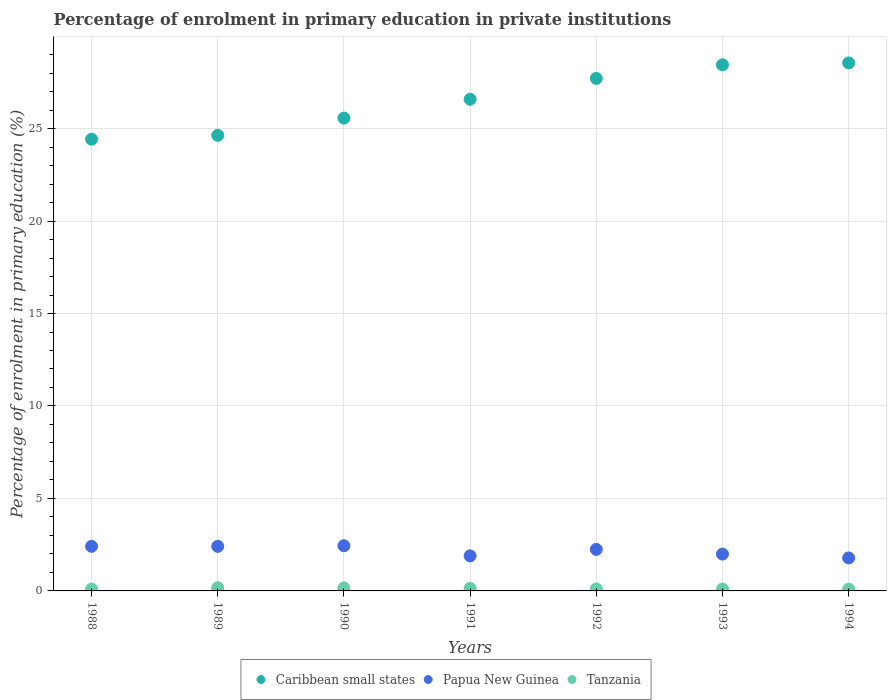How many different coloured dotlines are there?
Make the answer very short. 3. Is the number of dotlines equal to the number of legend labels?
Provide a succinct answer. Yes. What is the percentage of enrolment in primary education in Tanzania in 1989?
Offer a terse response. 0.17. Across all years, what is the maximum percentage of enrolment in primary education in Caribbean small states?
Offer a terse response. 28.55. Across all years, what is the minimum percentage of enrolment in primary education in Papua New Guinea?
Give a very brief answer. 1.78. In which year was the percentage of enrolment in primary education in Papua New Guinea maximum?
Provide a short and direct response. 1990. What is the total percentage of enrolment in primary education in Caribbean small states in the graph?
Make the answer very short. 185.92. What is the difference between the percentage of enrolment in primary education in Papua New Guinea in 1988 and that in 1989?
Your response must be concise. 0. What is the difference between the percentage of enrolment in primary education in Caribbean small states in 1993 and the percentage of enrolment in primary education in Papua New Guinea in 1992?
Offer a very short reply. 26.2. What is the average percentage of enrolment in primary education in Papua New Guinea per year?
Make the answer very short. 2.17. In the year 1990, what is the difference between the percentage of enrolment in primary education in Papua New Guinea and percentage of enrolment in primary education in Caribbean small states?
Offer a very short reply. -23.12. In how many years, is the percentage of enrolment in primary education in Tanzania greater than 20 %?
Ensure brevity in your answer.  0. What is the ratio of the percentage of enrolment in primary education in Papua New Guinea in 1991 to that in 1994?
Provide a succinct answer. 1.06. Is the difference between the percentage of enrolment in primary education in Papua New Guinea in 1990 and 1994 greater than the difference between the percentage of enrolment in primary education in Caribbean small states in 1990 and 1994?
Ensure brevity in your answer.  Yes. What is the difference between the highest and the second highest percentage of enrolment in primary education in Tanzania?
Ensure brevity in your answer.  0.01. What is the difference between the highest and the lowest percentage of enrolment in primary education in Tanzania?
Give a very brief answer. 0.08. In how many years, is the percentage of enrolment in primary education in Papua New Guinea greater than the average percentage of enrolment in primary education in Papua New Guinea taken over all years?
Offer a very short reply. 4. Is it the case that in every year, the sum of the percentage of enrolment in primary education in Papua New Guinea and percentage of enrolment in primary education in Tanzania  is greater than the percentage of enrolment in primary education in Caribbean small states?
Offer a very short reply. No. Does the percentage of enrolment in primary education in Tanzania monotonically increase over the years?
Give a very brief answer. No. Is the percentage of enrolment in primary education in Tanzania strictly greater than the percentage of enrolment in primary education in Caribbean small states over the years?
Provide a short and direct response. No. Is the percentage of enrolment in primary education in Caribbean small states strictly less than the percentage of enrolment in primary education in Papua New Guinea over the years?
Offer a very short reply. No. How many dotlines are there?
Make the answer very short. 3. How many years are there in the graph?
Ensure brevity in your answer.  7. What is the difference between two consecutive major ticks on the Y-axis?
Provide a short and direct response. 5. Are the values on the major ticks of Y-axis written in scientific E-notation?
Give a very brief answer. No. Where does the legend appear in the graph?
Make the answer very short. Bottom center. How many legend labels are there?
Your response must be concise. 3. How are the legend labels stacked?
Offer a terse response. Horizontal. What is the title of the graph?
Offer a terse response. Percentage of enrolment in primary education in private institutions. What is the label or title of the Y-axis?
Offer a terse response. Percentage of enrolment in primary education (%). What is the Percentage of enrolment in primary education (%) of Caribbean small states in 1988?
Your answer should be very brief. 24.43. What is the Percentage of enrolment in primary education (%) of Papua New Guinea in 1988?
Ensure brevity in your answer.  2.41. What is the Percentage of enrolment in primary education (%) in Tanzania in 1988?
Offer a very short reply. 0.1. What is the Percentage of enrolment in primary education (%) in Caribbean small states in 1989?
Provide a succinct answer. 24.64. What is the Percentage of enrolment in primary education (%) in Papua New Guinea in 1989?
Provide a succinct answer. 2.41. What is the Percentage of enrolment in primary education (%) of Tanzania in 1989?
Offer a very short reply. 0.17. What is the Percentage of enrolment in primary education (%) in Caribbean small states in 1990?
Offer a terse response. 25.57. What is the Percentage of enrolment in primary education (%) in Papua New Guinea in 1990?
Ensure brevity in your answer.  2.44. What is the Percentage of enrolment in primary education (%) in Tanzania in 1990?
Offer a very short reply. 0.17. What is the Percentage of enrolment in primary education (%) of Caribbean small states in 1991?
Your response must be concise. 26.59. What is the Percentage of enrolment in primary education (%) of Papua New Guinea in 1991?
Make the answer very short. 1.9. What is the Percentage of enrolment in primary education (%) of Tanzania in 1991?
Ensure brevity in your answer.  0.14. What is the Percentage of enrolment in primary education (%) in Caribbean small states in 1992?
Your answer should be compact. 27.71. What is the Percentage of enrolment in primary education (%) of Papua New Guinea in 1992?
Provide a succinct answer. 2.25. What is the Percentage of enrolment in primary education (%) of Tanzania in 1992?
Your response must be concise. 0.11. What is the Percentage of enrolment in primary education (%) of Caribbean small states in 1993?
Offer a very short reply. 28.45. What is the Percentage of enrolment in primary education (%) in Papua New Guinea in 1993?
Offer a very short reply. 1.99. What is the Percentage of enrolment in primary education (%) of Tanzania in 1993?
Your response must be concise. 0.1. What is the Percentage of enrolment in primary education (%) in Caribbean small states in 1994?
Give a very brief answer. 28.55. What is the Percentage of enrolment in primary education (%) of Papua New Guinea in 1994?
Offer a very short reply. 1.78. What is the Percentage of enrolment in primary education (%) in Tanzania in 1994?
Your answer should be very brief. 0.1. Across all years, what is the maximum Percentage of enrolment in primary education (%) in Caribbean small states?
Offer a very short reply. 28.55. Across all years, what is the maximum Percentage of enrolment in primary education (%) of Papua New Guinea?
Keep it short and to the point. 2.44. Across all years, what is the maximum Percentage of enrolment in primary education (%) of Tanzania?
Your answer should be very brief. 0.17. Across all years, what is the minimum Percentage of enrolment in primary education (%) of Caribbean small states?
Your response must be concise. 24.43. Across all years, what is the minimum Percentage of enrolment in primary education (%) of Papua New Guinea?
Make the answer very short. 1.78. Across all years, what is the minimum Percentage of enrolment in primary education (%) in Tanzania?
Ensure brevity in your answer.  0.1. What is the total Percentage of enrolment in primary education (%) in Caribbean small states in the graph?
Make the answer very short. 185.92. What is the total Percentage of enrolment in primary education (%) of Papua New Guinea in the graph?
Ensure brevity in your answer.  15.18. What is the total Percentage of enrolment in primary education (%) in Tanzania in the graph?
Keep it short and to the point. 0.89. What is the difference between the Percentage of enrolment in primary education (%) in Caribbean small states in 1988 and that in 1989?
Your answer should be compact. -0.21. What is the difference between the Percentage of enrolment in primary education (%) in Tanzania in 1988 and that in 1989?
Your answer should be very brief. -0.08. What is the difference between the Percentage of enrolment in primary education (%) in Caribbean small states in 1988 and that in 1990?
Your answer should be compact. -1.14. What is the difference between the Percentage of enrolment in primary education (%) of Papua New Guinea in 1988 and that in 1990?
Provide a short and direct response. -0.03. What is the difference between the Percentage of enrolment in primary education (%) of Tanzania in 1988 and that in 1990?
Your answer should be compact. -0.07. What is the difference between the Percentage of enrolment in primary education (%) in Caribbean small states in 1988 and that in 1991?
Provide a short and direct response. -2.16. What is the difference between the Percentage of enrolment in primary education (%) in Papua New Guinea in 1988 and that in 1991?
Offer a very short reply. 0.52. What is the difference between the Percentage of enrolment in primary education (%) in Tanzania in 1988 and that in 1991?
Give a very brief answer. -0.04. What is the difference between the Percentage of enrolment in primary education (%) of Caribbean small states in 1988 and that in 1992?
Give a very brief answer. -3.29. What is the difference between the Percentage of enrolment in primary education (%) of Papua New Guinea in 1988 and that in 1992?
Your answer should be compact. 0.17. What is the difference between the Percentage of enrolment in primary education (%) of Tanzania in 1988 and that in 1992?
Your answer should be very brief. -0.01. What is the difference between the Percentage of enrolment in primary education (%) of Caribbean small states in 1988 and that in 1993?
Ensure brevity in your answer.  -4.02. What is the difference between the Percentage of enrolment in primary education (%) of Papua New Guinea in 1988 and that in 1993?
Provide a short and direct response. 0.42. What is the difference between the Percentage of enrolment in primary education (%) of Tanzania in 1988 and that in 1993?
Provide a short and direct response. -0. What is the difference between the Percentage of enrolment in primary education (%) in Caribbean small states in 1988 and that in 1994?
Make the answer very short. -4.13. What is the difference between the Percentage of enrolment in primary education (%) of Papua New Guinea in 1988 and that in 1994?
Offer a very short reply. 0.63. What is the difference between the Percentage of enrolment in primary education (%) of Tanzania in 1988 and that in 1994?
Ensure brevity in your answer.  0. What is the difference between the Percentage of enrolment in primary education (%) of Caribbean small states in 1989 and that in 1990?
Keep it short and to the point. -0.93. What is the difference between the Percentage of enrolment in primary education (%) in Papua New Guinea in 1989 and that in 1990?
Your response must be concise. -0.03. What is the difference between the Percentage of enrolment in primary education (%) of Tanzania in 1989 and that in 1990?
Ensure brevity in your answer.  0.01. What is the difference between the Percentage of enrolment in primary education (%) in Caribbean small states in 1989 and that in 1991?
Your answer should be compact. -1.95. What is the difference between the Percentage of enrolment in primary education (%) in Papua New Guinea in 1989 and that in 1991?
Offer a very short reply. 0.52. What is the difference between the Percentage of enrolment in primary education (%) of Tanzania in 1989 and that in 1991?
Your answer should be very brief. 0.03. What is the difference between the Percentage of enrolment in primary education (%) in Caribbean small states in 1989 and that in 1992?
Give a very brief answer. -3.08. What is the difference between the Percentage of enrolment in primary education (%) in Papua New Guinea in 1989 and that in 1992?
Offer a terse response. 0.16. What is the difference between the Percentage of enrolment in primary education (%) in Tanzania in 1989 and that in 1992?
Keep it short and to the point. 0.07. What is the difference between the Percentage of enrolment in primary education (%) in Caribbean small states in 1989 and that in 1993?
Provide a succinct answer. -3.81. What is the difference between the Percentage of enrolment in primary education (%) of Papua New Guinea in 1989 and that in 1993?
Offer a very short reply. 0.42. What is the difference between the Percentage of enrolment in primary education (%) of Tanzania in 1989 and that in 1993?
Provide a succinct answer. 0.07. What is the difference between the Percentage of enrolment in primary education (%) in Caribbean small states in 1989 and that in 1994?
Provide a short and direct response. -3.92. What is the difference between the Percentage of enrolment in primary education (%) of Papua New Guinea in 1989 and that in 1994?
Offer a very short reply. 0.63. What is the difference between the Percentage of enrolment in primary education (%) of Tanzania in 1989 and that in 1994?
Your response must be concise. 0.08. What is the difference between the Percentage of enrolment in primary education (%) of Caribbean small states in 1990 and that in 1991?
Offer a very short reply. -1.02. What is the difference between the Percentage of enrolment in primary education (%) in Papua New Guinea in 1990 and that in 1991?
Keep it short and to the point. 0.55. What is the difference between the Percentage of enrolment in primary education (%) in Tanzania in 1990 and that in 1991?
Your answer should be very brief. 0.03. What is the difference between the Percentage of enrolment in primary education (%) in Caribbean small states in 1990 and that in 1992?
Offer a terse response. -2.15. What is the difference between the Percentage of enrolment in primary education (%) in Papua New Guinea in 1990 and that in 1992?
Your answer should be compact. 0.2. What is the difference between the Percentage of enrolment in primary education (%) in Tanzania in 1990 and that in 1992?
Offer a terse response. 0.06. What is the difference between the Percentage of enrolment in primary education (%) of Caribbean small states in 1990 and that in 1993?
Give a very brief answer. -2.88. What is the difference between the Percentage of enrolment in primary education (%) in Papua New Guinea in 1990 and that in 1993?
Make the answer very short. 0.45. What is the difference between the Percentage of enrolment in primary education (%) in Tanzania in 1990 and that in 1993?
Keep it short and to the point. 0.07. What is the difference between the Percentage of enrolment in primary education (%) in Caribbean small states in 1990 and that in 1994?
Offer a very short reply. -2.99. What is the difference between the Percentage of enrolment in primary education (%) of Papua New Guinea in 1990 and that in 1994?
Provide a succinct answer. 0.66. What is the difference between the Percentage of enrolment in primary education (%) in Tanzania in 1990 and that in 1994?
Give a very brief answer. 0.07. What is the difference between the Percentage of enrolment in primary education (%) of Caribbean small states in 1991 and that in 1992?
Your response must be concise. -1.13. What is the difference between the Percentage of enrolment in primary education (%) in Papua New Guinea in 1991 and that in 1992?
Your response must be concise. -0.35. What is the difference between the Percentage of enrolment in primary education (%) of Tanzania in 1991 and that in 1992?
Your response must be concise. 0.03. What is the difference between the Percentage of enrolment in primary education (%) of Caribbean small states in 1991 and that in 1993?
Provide a succinct answer. -1.86. What is the difference between the Percentage of enrolment in primary education (%) of Papua New Guinea in 1991 and that in 1993?
Your answer should be compact. -0.1. What is the difference between the Percentage of enrolment in primary education (%) of Tanzania in 1991 and that in 1993?
Your answer should be very brief. 0.04. What is the difference between the Percentage of enrolment in primary education (%) of Caribbean small states in 1991 and that in 1994?
Your response must be concise. -1.97. What is the difference between the Percentage of enrolment in primary education (%) in Papua New Guinea in 1991 and that in 1994?
Provide a succinct answer. 0.11. What is the difference between the Percentage of enrolment in primary education (%) in Tanzania in 1991 and that in 1994?
Your answer should be compact. 0.05. What is the difference between the Percentage of enrolment in primary education (%) in Caribbean small states in 1992 and that in 1993?
Make the answer very short. -0.73. What is the difference between the Percentage of enrolment in primary education (%) in Papua New Guinea in 1992 and that in 1993?
Offer a terse response. 0.25. What is the difference between the Percentage of enrolment in primary education (%) in Tanzania in 1992 and that in 1993?
Provide a short and direct response. 0.01. What is the difference between the Percentage of enrolment in primary education (%) of Caribbean small states in 1992 and that in 1994?
Your response must be concise. -0.84. What is the difference between the Percentage of enrolment in primary education (%) in Papua New Guinea in 1992 and that in 1994?
Your response must be concise. 0.46. What is the difference between the Percentage of enrolment in primary education (%) of Tanzania in 1992 and that in 1994?
Give a very brief answer. 0.01. What is the difference between the Percentage of enrolment in primary education (%) of Caribbean small states in 1993 and that in 1994?
Ensure brevity in your answer.  -0.11. What is the difference between the Percentage of enrolment in primary education (%) in Papua New Guinea in 1993 and that in 1994?
Offer a terse response. 0.21. What is the difference between the Percentage of enrolment in primary education (%) in Tanzania in 1993 and that in 1994?
Offer a very short reply. 0.01. What is the difference between the Percentage of enrolment in primary education (%) of Caribbean small states in 1988 and the Percentage of enrolment in primary education (%) of Papua New Guinea in 1989?
Keep it short and to the point. 22.02. What is the difference between the Percentage of enrolment in primary education (%) of Caribbean small states in 1988 and the Percentage of enrolment in primary education (%) of Tanzania in 1989?
Your response must be concise. 24.25. What is the difference between the Percentage of enrolment in primary education (%) in Papua New Guinea in 1988 and the Percentage of enrolment in primary education (%) in Tanzania in 1989?
Provide a short and direct response. 2.24. What is the difference between the Percentage of enrolment in primary education (%) of Caribbean small states in 1988 and the Percentage of enrolment in primary education (%) of Papua New Guinea in 1990?
Your answer should be very brief. 21.98. What is the difference between the Percentage of enrolment in primary education (%) in Caribbean small states in 1988 and the Percentage of enrolment in primary education (%) in Tanzania in 1990?
Offer a terse response. 24.26. What is the difference between the Percentage of enrolment in primary education (%) of Papua New Guinea in 1988 and the Percentage of enrolment in primary education (%) of Tanzania in 1990?
Ensure brevity in your answer.  2.24. What is the difference between the Percentage of enrolment in primary education (%) in Caribbean small states in 1988 and the Percentage of enrolment in primary education (%) in Papua New Guinea in 1991?
Your response must be concise. 22.53. What is the difference between the Percentage of enrolment in primary education (%) of Caribbean small states in 1988 and the Percentage of enrolment in primary education (%) of Tanzania in 1991?
Provide a succinct answer. 24.28. What is the difference between the Percentage of enrolment in primary education (%) of Papua New Guinea in 1988 and the Percentage of enrolment in primary education (%) of Tanzania in 1991?
Offer a very short reply. 2.27. What is the difference between the Percentage of enrolment in primary education (%) in Caribbean small states in 1988 and the Percentage of enrolment in primary education (%) in Papua New Guinea in 1992?
Keep it short and to the point. 22.18. What is the difference between the Percentage of enrolment in primary education (%) of Caribbean small states in 1988 and the Percentage of enrolment in primary education (%) of Tanzania in 1992?
Provide a short and direct response. 24.32. What is the difference between the Percentage of enrolment in primary education (%) in Papua New Guinea in 1988 and the Percentage of enrolment in primary education (%) in Tanzania in 1992?
Ensure brevity in your answer.  2.3. What is the difference between the Percentage of enrolment in primary education (%) in Caribbean small states in 1988 and the Percentage of enrolment in primary education (%) in Papua New Guinea in 1993?
Make the answer very short. 22.43. What is the difference between the Percentage of enrolment in primary education (%) in Caribbean small states in 1988 and the Percentage of enrolment in primary education (%) in Tanzania in 1993?
Provide a short and direct response. 24.32. What is the difference between the Percentage of enrolment in primary education (%) of Papua New Guinea in 1988 and the Percentage of enrolment in primary education (%) of Tanzania in 1993?
Give a very brief answer. 2.31. What is the difference between the Percentage of enrolment in primary education (%) of Caribbean small states in 1988 and the Percentage of enrolment in primary education (%) of Papua New Guinea in 1994?
Your response must be concise. 22.64. What is the difference between the Percentage of enrolment in primary education (%) of Caribbean small states in 1988 and the Percentage of enrolment in primary education (%) of Tanzania in 1994?
Provide a succinct answer. 24.33. What is the difference between the Percentage of enrolment in primary education (%) in Papua New Guinea in 1988 and the Percentage of enrolment in primary education (%) in Tanzania in 1994?
Give a very brief answer. 2.31. What is the difference between the Percentage of enrolment in primary education (%) of Caribbean small states in 1989 and the Percentage of enrolment in primary education (%) of Papua New Guinea in 1990?
Give a very brief answer. 22.19. What is the difference between the Percentage of enrolment in primary education (%) in Caribbean small states in 1989 and the Percentage of enrolment in primary education (%) in Tanzania in 1990?
Your response must be concise. 24.47. What is the difference between the Percentage of enrolment in primary education (%) of Papua New Guinea in 1989 and the Percentage of enrolment in primary education (%) of Tanzania in 1990?
Make the answer very short. 2.24. What is the difference between the Percentage of enrolment in primary education (%) of Caribbean small states in 1989 and the Percentage of enrolment in primary education (%) of Papua New Guinea in 1991?
Your answer should be very brief. 22.74. What is the difference between the Percentage of enrolment in primary education (%) of Caribbean small states in 1989 and the Percentage of enrolment in primary education (%) of Tanzania in 1991?
Provide a succinct answer. 24.49. What is the difference between the Percentage of enrolment in primary education (%) of Papua New Guinea in 1989 and the Percentage of enrolment in primary education (%) of Tanzania in 1991?
Your answer should be very brief. 2.27. What is the difference between the Percentage of enrolment in primary education (%) in Caribbean small states in 1989 and the Percentage of enrolment in primary education (%) in Papua New Guinea in 1992?
Provide a succinct answer. 22.39. What is the difference between the Percentage of enrolment in primary education (%) of Caribbean small states in 1989 and the Percentage of enrolment in primary education (%) of Tanzania in 1992?
Offer a very short reply. 24.53. What is the difference between the Percentage of enrolment in primary education (%) in Papua New Guinea in 1989 and the Percentage of enrolment in primary education (%) in Tanzania in 1992?
Give a very brief answer. 2.3. What is the difference between the Percentage of enrolment in primary education (%) of Caribbean small states in 1989 and the Percentage of enrolment in primary education (%) of Papua New Guinea in 1993?
Provide a short and direct response. 22.64. What is the difference between the Percentage of enrolment in primary education (%) of Caribbean small states in 1989 and the Percentage of enrolment in primary education (%) of Tanzania in 1993?
Give a very brief answer. 24.53. What is the difference between the Percentage of enrolment in primary education (%) of Papua New Guinea in 1989 and the Percentage of enrolment in primary education (%) of Tanzania in 1993?
Ensure brevity in your answer.  2.31. What is the difference between the Percentage of enrolment in primary education (%) of Caribbean small states in 1989 and the Percentage of enrolment in primary education (%) of Papua New Guinea in 1994?
Your response must be concise. 22.85. What is the difference between the Percentage of enrolment in primary education (%) in Caribbean small states in 1989 and the Percentage of enrolment in primary education (%) in Tanzania in 1994?
Offer a terse response. 24.54. What is the difference between the Percentage of enrolment in primary education (%) in Papua New Guinea in 1989 and the Percentage of enrolment in primary education (%) in Tanzania in 1994?
Your answer should be very brief. 2.31. What is the difference between the Percentage of enrolment in primary education (%) in Caribbean small states in 1990 and the Percentage of enrolment in primary education (%) in Papua New Guinea in 1991?
Your answer should be compact. 23.67. What is the difference between the Percentage of enrolment in primary education (%) in Caribbean small states in 1990 and the Percentage of enrolment in primary education (%) in Tanzania in 1991?
Give a very brief answer. 25.43. What is the difference between the Percentage of enrolment in primary education (%) of Papua New Guinea in 1990 and the Percentage of enrolment in primary education (%) of Tanzania in 1991?
Make the answer very short. 2.3. What is the difference between the Percentage of enrolment in primary education (%) in Caribbean small states in 1990 and the Percentage of enrolment in primary education (%) in Papua New Guinea in 1992?
Offer a terse response. 23.32. What is the difference between the Percentage of enrolment in primary education (%) of Caribbean small states in 1990 and the Percentage of enrolment in primary education (%) of Tanzania in 1992?
Offer a terse response. 25.46. What is the difference between the Percentage of enrolment in primary education (%) in Papua New Guinea in 1990 and the Percentage of enrolment in primary education (%) in Tanzania in 1992?
Your response must be concise. 2.33. What is the difference between the Percentage of enrolment in primary education (%) in Caribbean small states in 1990 and the Percentage of enrolment in primary education (%) in Papua New Guinea in 1993?
Make the answer very short. 23.58. What is the difference between the Percentage of enrolment in primary education (%) in Caribbean small states in 1990 and the Percentage of enrolment in primary education (%) in Tanzania in 1993?
Give a very brief answer. 25.47. What is the difference between the Percentage of enrolment in primary education (%) in Papua New Guinea in 1990 and the Percentage of enrolment in primary education (%) in Tanzania in 1993?
Ensure brevity in your answer.  2.34. What is the difference between the Percentage of enrolment in primary education (%) of Caribbean small states in 1990 and the Percentage of enrolment in primary education (%) of Papua New Guinea in 1994?
Your answer should be compact. 23.78. What is the difference between the Percentage of enrolment in primary education (%) of Caribbean small states in 1990 and the Percentage of enrolment in primary education (%) of Tanzania in 1994?
Make the answer very short. 25.47. What is the difference between the Percentage of enrolment in primary education (%) in Papua New Guinea in 1990 and the Percentage of enrolment in primary education (%) in Tanzania in 1994?
Ensure brevity in your answer.  2.35. What is the difference between the Percentage of enrolment in primary education (%) of Caribbean small states in 1991 and the Percentage of enrolment in primary education (%) of Papua New Guinea in 1992?
Keep it short and to the point. 24.34. What is the difference between the Percentage of enrolment in primary education (%) of Caribbean small states in 1991 and the Percentage of enrolment in primary education (%) of Tanzania in 1992?
Your answer should be compact. 26.48. What is the difference between the Percentage of enrolment in primary education (%) of Papua New Guinea in 1991 and the Percentage of enrolment in primary education (%) of Tanzania in 1992?
Ensure brevity in your answer.  1.79. What is the difference between the Percentage of enrolment in primary education (%) of Caribbean small states in 1991 and the Percentage of enrolment in primary education (%) of Papua New Guinea in 1993?
Offer a very short reply. 24.59. What is the difference between the Percentage of enrolment in primary education (%) in Caribbean small states in 1991 and the Percentage of enrolment in primary education (%) in Tanzania in 1993?
Keep it short and to the point. 26.48. What is the difference between the Percentage of enrolment in primary education (%) in Papua New Guinea in 1991 and the Percentage of enrolment in primary education (%) in Tanzania in 1993?
Ensure brevity in your answer.  1.79. What is the difference between the Percentage of enrolment in primary education (%) of Caribbean small states in 1991 and the Percentage of enrolment in primary education (%) of Papua New Guinea in 1994?
Give a very brief answer. 24.8. What is the difference between the Percentage of enrolment in primary education (%) of Caribbean small states in 1991 and the Percentage of enrolment in primary education (%) of Tanzania in 1994?
Your response must be concise. 26.49. What is the difference between the Percentage of enrolment in primary education (%) in Papua New Guinea in 1991 and the Percentage of enrolment in primary education (%) in Tanzania in 1994?
Your answer should be very brief. 1.8. What is the difference between the Percentage of enrolment in primary education (%) of Caribbean small states in 1992 and the Percentage of enrolment in primary education (%) of Papua New Guinea in 1993?
Give a very brief answer. 25.72. What is the difference between the Percentage of enrolment in primary education (%) in Caribbean small states in 1992 and the Percentage of enrolment in primary education (%) in Tanzania in 1993?
Ensure brevity in your answer.  27.61. What is the difference between the Percentage of enrolment in primary education (%) in Papua New Guinea in 1992 and the Percentage of enrolment in primary education (%) in Tanzania in 1993?
Your answer should be very brief. 2.14. What is the difference between the Percentage of enrolment in primary education (%) in Caribbean small states in 1992 and the Percentage of enrolment in primary education (%) in Papua New Guinea in 1994?
Give a very brief answer. 25.93. What is the difference between the Percentage of enrolment in primary education (%) in Caribbean small states in 1992 and the Percentage of enrolment in primary education (%) in Tanzania in 1994?
Offer a terse response. 27.62. What is the difference between the Percentage of enrolment in primary education (%) of Papua New Guinea in 1992 and the Percentage of enrolment in primary education (%) of Tanzania in 1994?
Your answer should be very brief. 2.15. What is the difference between the Percentage of enrolment in primary education (%) in Caribbean small states in 1993 and the Percentage of enrolment in primary education (%) in Papua New Guinea in 1994?
Give a very brief answer. 26.66. What is the difference between the Percentage of enrolment in primary education (%) of Caribbean small states in 1993 and the Percentage of enrolment in primary education (%) of Tanzania in 1994?
Provide a succinct answer. 28.35. What is the difference between the Percentage of enrolment in primary education (%) in Papua New Guinea in 1993 and the Percentage of enrolment in primary education (%) in Tanzania in 1994?
Ensure brevity in your answer.  1.9. What is the average Percentage of enrolment in primary education (%) in Caribbean small states per year?
Your answer should be compact. 26.56. What is the average Percentage of enrolment in primary education (%) of Papua New Guinea per year?
Offer a very short reply. 2.17. What is the average Percentage of enrolment in primary education (%) in Tanzania per year?
Give a very brief answer. 0.13. In the year 1988, what is the difference between the Percentage of enrolment in primary education (%) in Caribbean small states and Percentage of enrolment in primary education (%) in Papua New Guinea?
Your answer should be compact. 22.01. In the year 1988, what is the difference between the Percentage of enrolment in primary education (%) of Caribbean small states and Percentage of enrolment in primary education (%) of Tanzania?
Ensure brevity in your answer.  24.33. In the year 1988, what is the difference between the Percentage of enrolment in primary education (%) in Papua New Guinea and Percentage of enrolment in primary education (%) in Tanzania?
Give a very brief answer. 2.31. In the year 1989, what is the difference between the Percentage of enrolment in primary education (%) of Caribbean small states and Percentage of enrolment in primary education (%) of Papua New Guinea?
Offer a very short reply. 22.23. In the year 1989, what is the difference between the Percentage of enrolment in primary education (%) in Caribbean small states and Percentage of enrolment in primary education (%) in Tanzania?
Offer a terse response. 24.46. In the year 1989, what is the difference between the Percentage of enrolment in primary education (%) of Papua New Guinea and Percentage of enrolment in primary education (%) of Tanzania?
Your answer should be compact. 2.24. In the year 1990, what is the difference between the Percentage of enrolment in primary education (%) of Caribbean small states and Percentage of enrolment in primary education (%) of Papua New Guinea?
Keep it short and to the point. 23.12. In the year 1990, what is the difference between the Percentage of enrolment in primary education (%) in Caribbean small states and Percentage of enrolment in primary education (%) in Tanzania?
Offer a terse response. 25.4. In the year 1990, what is the difference between the Percentage of enrolment in primary education (%) of Papua New Guinea and Percentage of enrolment in primary education (%) of Tanzania?
Ensure brevity in your answer.  2.28. In the year 1991, what is the difference between the Percentage of enrolment in primary education (%) in Caribbean small states and Percentage of enrolment in primary education (%) in Papua New Guinea?
Your response must be concise. 24.69. In the year 1991, what is the difference between the Percentage of enrolment in primary education (%) in Caribbean small states and Percentage of enrolment in primary education (%) in Tanzania?
Your response must be concise. 26.44. In the year 1991, what is the difference between the Percentage of enrolment in primary education (%) in Papua New Guinea and Percentage of enrolment in primary education (%) in Tanzania?
Make the answer very short. 1.75. In the year 1992, what is the difference between the Percentage of enrolment in primary education (%) of Caribbean small states and Percentage of enrolment in primary education (%) of Papua New Guinea?
Your answer should be compact. 25.47. In the year 1992, what is the difference between the Percentage of enrolment in primary education (%) in Caribbean small states and Percentage of enrolment in primary education (%) in Tanzania?
Provide a succinct answer. 27.6. In the year 1992, what is the difference between the Percentage of enrolment in primary education (%) in Papua New Guinea and Percentage of enrolment in primary education (%) in Tanzania?
Provide a short and direct response. 2.14. In the year 1993, what is the difference between the Percentage of enrolment in primary education (%) in Caribbean small states and Percentage of enrolment in primary education (%) in Papua New Guinea?
Your answer should be very brief. 26.45. In the year 1993, what is the difference between the Percentage of enrolment in primary education (%) in Caribbean small states and Percentage of enrolment in primary education (%) in Tanzania?
Give a very brief answer. 28.34. In the year 1993, what is the difference between the Percentage of enrolment in primary education (%) in Papua New Guinea and Percentage of enrolment in primary education (%) in Tanzania?
Offer a terse response. 1.89. In the year 1994, what is the difference between the Percentage of enrolment in primary education (%) of Caribbean small states and Percentage of enrolment in primary education (%) of Papua New Guinea?
Provide a short and direct response. 26.77. In the year 1994, what is the difference between the Percentage of enrolment in primary education (%) of Caribbean small states and Percentage of enrolment in primary education (%) of Tanzania?
Your response must be concise. 28.46. In the year 1994, what is the difference between the Percentage of enrolment in primary education (%) in Papua New Guinea and Percentage of enrolment in primary education (%) in Tanzania?
Offer a terse response. 1.69. What is the ratio of the Percentage of enrolment in primary education (%) in Papua New Guinea in 1988 to that in 1989?
Your response must be concise. 1. What is the ratio of the Percentage of enrolment in primary education (%) of Tanzania in 1988 to that in 1989?
Your answer should be compact. 0.56. What is the ratio of the Percentage of enrolment in primary education (%) in Caribbean small states in 1988 to that in 1990?
Your answer should be compact. 0.96. What is the ratio of the Percentage of enrolment in primary education (%) in Papua New Guinea in 1988 to that in 1990?
Keep it short and to the point. 0.99. What is the ratio of the Percentage of enrolment in primary education (%) in Tanzania in 1988 to that in 1990?
Your response must be concise. 0.59. What is the ratio of the Percentage of enrolment in primary education (%) of Caribbean small states in 1988 to that in 1991?
Offer a terse response. 0.92. What is the ratio of the Percentage of enrolment in primary education (%) of Papua New Guinea in 1988 to that in 1991?
Your response must be concise. 1.27. What is the ratio of the Percentage of enrolment in primary education (%) of Tanzania in 1988 to that in 1991?
Your response must be concise. 0.69. What is the ratio of the Percentage of enrolment in primary education (%) in Caribbean small states in 1988 to that in 1992?
Your answer should be very brief. 0.88. What is the ratio of the Percentage of enrolment in primary education (%) of Papua New Guinea in 1988 to that in 1992?
Offer a very short reply. 1.07. What is the ratio of the Percentage of enrolment in primary education (%) in Tanzania in 1988 to that in 1992?
Your answer should be compact. 0.9. What is the ratio of the Percentage of enrolment in primary education (%) in Caribbean small states in 1988 to that in 1993?
Your answer should be compact. 0.86. What is the ratio of the Percentage of enrolment in primary education (%) in Papua New Guinea in 1988 to that in 1993?
Your answer should be compact. 1.21. What is the ratio of the Percentage of enrolment in primary education (%) of Tanzania in 1988 to that in 1993?
Provide a short and direct response. 0.96. What is the ratio of the Percentage of enrolment in primary education (%) in Caribbean small states in 1988 to that in 1994?
Your response must be concise. 0.86. What is the ratio of the Percentage of enrolment in primary education (%) in Papua New Guinea in 1988 to that in 1994?
Provide a succinct answer. 1.35. What is the ratio of the Percentage of enrolment in primary education (%) of Tanzania in 1988 to that in 1994?
Provide a succinct answer. 1.02. What is the ratio of the Percentage of enrolment in primary education (%) in Caribbean small states in 1989 to that in 1990?
Make the answer very short. 0.96. What is the ratio of the Percentage of enrolment in primary education (%) in Tanzania in 1989 to that in 1990?
Provide a short and direct response. 1.04. What is the ratio of the Percentage of enrolment in primary education (%) in Caribbean small states in 1989 to that in 1991?
Your answer should be very brief. 0.93. What is the ratio of the Percentage of enrolment in primary education (%) of Papua New Guinea in 1989 to that in 1991?
Provide a short and direct response. 1.27. What is the ratio of the Percentage of enrolment in primary education (%) in Tanzania in 1989 to that in 1991?
Offer a terse response. 1.23. What is the ratio of the Percentage of enrolment in primary education (%) of Caribbean small states in 1989 to that in 1992?
Give a very brief answer. 0.89. What is the ratio of the Percentage of enrolment in primary education (%) of Papua New Guinea in 1989 to that in 1992?
Your answer should be very brief. 1.07. What is the ratio of the Percentage of enrolment in primary education (%) of Tanzania in 1989 to that in 1992?
Your response must be concise. 1.6. What is the ratio of the Percentage of enrolment in primary education (%) of Caribbean small states in 1989 to that in 1993?
Your response must be concise. 0.87. What is the ratio of the Percentage of enrolment in primary education (%) of Papua New Guinea in 1989 to that in 1993?
Offer a terse response. 1.21. What is the ratio of the Percentage of enrolment in primary education (%) in Tanzania in 1989 to that in 1993?
Provide a short and direct response. 1.71. What is the ratio of the Percentage of enrolment in primary education (%) in Caribbean small states in 1989 to that in 1994?
Offer a very short reply. 0.86. What is the ratio of the Percentage of enrolment in primary education (%) in Papua New Guinea in 1989 to that in 1994?
Your response must be concise. 1.35. What is the ratio of the Percentage of enrolment in primary education (%) in Tanzania in 1989 to that in 1994?
Your answer should be very brief. 1.82. What is the ratio of the Percentage of enrolment in primary education (%) of Caribbean small states in 1990 to that in 1991?
Keep it short and to the point. 0.96. What is the ratio of the Percentage of enrolment in primary education (%) of Papua New Guinea in 1990 to that in 1991?
Offer a very short reply. 1.29. What is the ratio of the Percentage of enrolment in primary education (%) of Tanzania in 1990 to that in 1991?
Make the answer very short. 1.18. What is the ratio of the Percentage of enrolment in primary education (%) of Caribbean small states in 1990 to that in 1992?
Offer a very short reply. 0.92. What is the ratio of the Percentage of enrolment in primary education (%) of Papua New Guinea in 1990 to that in 1992?
Offer a very short reply. 1.09. What is the ratio of the Percentage of enrolment in primary education (%) of Tanzania in 1990 to that in 1992?
Your response must be concise. 1.54. What is the ratio of the Percentage of enrolment in primary education (%) in Caribbean small states in 1990 to that in 1993?
Offer a very short reply. 0.9. What is the ratio of the Percentage of enrolment in primary education (%) in Papua New Guinea in 1990 to that in 1993?
Provide a short and direct response. 1.23. What is the ratio of the Percentage of enrolment in primary education (%) of Tanzania in 1990 to that in 1993?
Ensure brevity in your answer.  1.64. What is the ratio of the Percentage of enrolment in primary education (%) in Caribbean small states in 1990 to that in 1994?
Ensure brevity in your answer.  0.9. What is the ratio of the Percentage of enrolment in primary education (%) in Papua New Guinea in 1990 to that in 1994?
Offer a very short reply. 1.37. What is the ratio of the Percentage of enrolment in primary education (%) in Tanzania in 1990 to that in 1994?
Offer a very short reply. 1.75. What is the ratio of the Percentage of enrolment in primary education (%) of Caribbean small states in 1991 to that in 1992?
Provide a short and direct response. 0.96. What is the ratio of the Percentage of enrolment in primary education (%) in Papua New Guinea in 1991 to that in 1992?
Keep it short and to the point. 0.84. What is the ratio of the Percentage of enrolment in primary education (%) of Tanzania in 1991 to that in 1992?
Make the answer very short. 1.3. What is the ratio of the Percentage of enrolment in primary education (%) of Caribbean small states in 1991 to that in 1993?
Your answer should be very brief. 0.93. What is the ratio of the Percentage of enrolment in primary education (%) in Papua New Guinea in 1991 to that in 1993?
Offer a terse response. 0.95. What is the ratio of the Percentage of enrolment in primary education (%) in Tanzania in 1991 to that in 1993?
Your response must be concise. 1.39. What is the ratio of the Percentage of enrolment in primary education (%) in Caribbean small states in 1991 to that in 1994?
Provide a short and direct response. 0.93. What is the ratio of the Percentage of enrolment in primary education (%) in Papua New Guinea in 1991 to that in 1994?
Provide a succinct answer. 1.06. What is the ratio of the Percentage of enrolment in primary education (%) of Tanzania in 1991 to that in 1994?
Give a very brief answer. 1.48. What is the ratio of the Percentage of enrolment in primary education (%) in Caribbean small states in 1992 to that in 1993?
Make the answer very short. 0.97. What is the ratio of the Percentage of enrolment in primary education (%) in Papua New Guinea in 1992 to that in 1993?
Provide a succinct answer. 1.13. What is the ratio of the Percentage of enrolment in primary education (%) in Tanzania in 1992 to that in 1993?
Provide a short and direct response. 1.07. What is the ratio of the Percentage of enrolment in primary education (%) in Caribbean small states in 1992 to that in 1994?
Ensure brevity in your answer.  0.97. What is the ratio of the Percentage of enrolment in primary education (%) of Papua New Guinea in 1992 to that in 1994?
Provide a short and direct response. 1.26. What is the ratio of the Percentage of enrolment in primary education (%) in Tanzania in 1992 to that in 1994?
Keep it short and to the point. 1.13. What is the ratio of the Percentage of enrolment in primary education (%) in Papua New Guinea in 1993 to that in 1994?
Give a very brief answer. 1.12. What is the ratio of the Percentage of enrolment in primary education (%) in Tanzania in 1993 to that in 1994?
Ensure brevity in your answer.  1.06. What is the difference between the highest and the second highest Percentage of enrolment in primary education (%) in Caribbean small states?
Offer a terse response. 0.11. What is the difference between the highest and the second highest Percentage of enrolment in primary education (%) of Papua New Guinea?
Provide a succinct answer. 0.03. What is the difference between the highest and the second highest Percentage of enrolment in primary education (%) in Tanzania?
Your answer should be very brief. 0.01. What is the difference between the highest and the lowest Percentage of enrolment in primary education (%) of Caribbean small states?
Keep it short and to the point. 4.13. What is the difference between the highest and the lowest Percentage of enrolment in primary education (%) in Papua New Guinea?
Offer a terse response. 0.66. What is the difference between the highest and the lowest Percentage of enrolment in primary education (%) of Tanzania?
Make the answer very short. 0.08. 